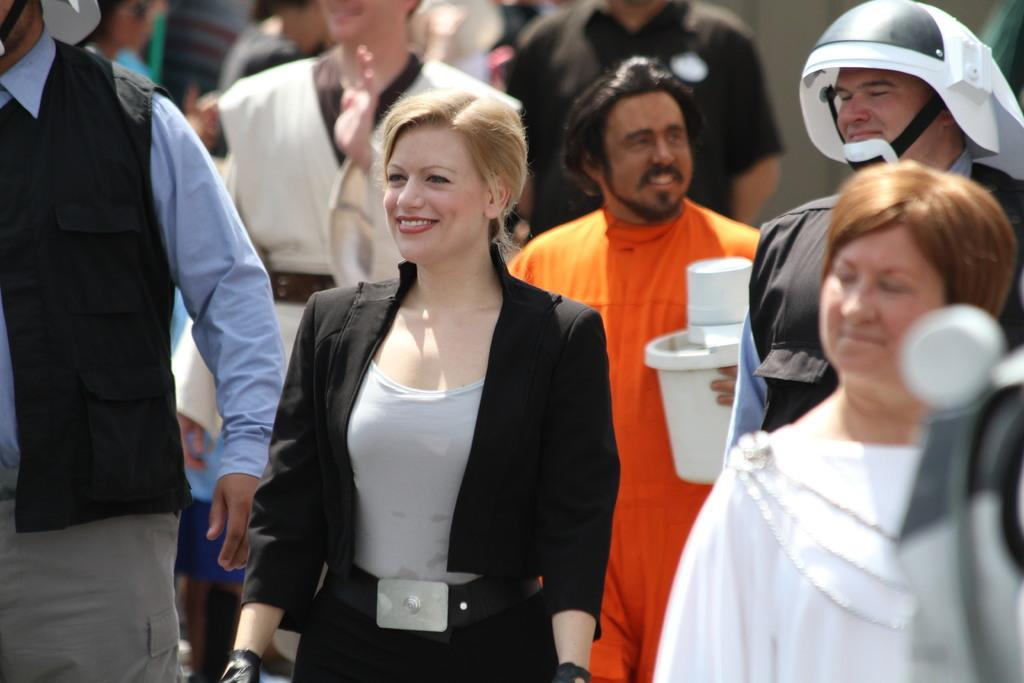Who is the main subject in the image? There is a lady in the image. What is the lady wearing? The lady is wearing a black jacket and a grey t-shirt. What is the lady doing in the image? The lady is standing and smiling. Are there any other people in the image? Yes, there are many people standing behind the lady. What type of credit does the lady have in the image? There is no mention of credit in the image, as it focuses on the lady and her clothing and actions. 